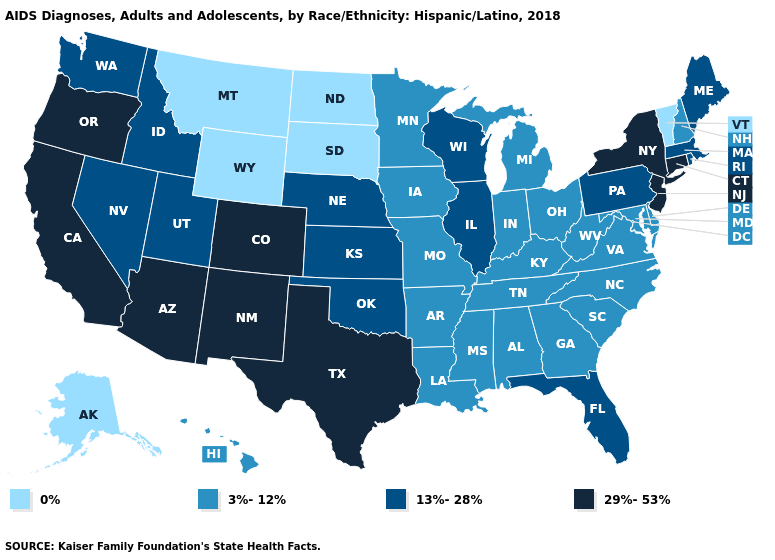Name the states that have a value in the range 3%-12%?
Write a very short answer. Alabama, Arkansas, Delaware, Georgia, Hawaii, Indiana, Iowa, Kentucky, Louisiana, Maryland, Michigan, Minnesota, Mississippi, Missouri, New Hampshire, North Carolina, Ohio, South Carolina, Tennessee, Virginia, West Virginia. Name the states that have a value in the range 0%?
Short answer required. Alaska, Montana, North Dakota, South Dakota, Vermont, Wyoming. What is the highest value in states that border Ohio?
Write a very short answer. 13%-28%. Which states have the lowest value in the USA?
Short answer required. Alaska, Montana, North Dakota, South Dakota, Vermont, Wyoming. Which states have the lowest value in the USA?
Keep it brief. Alaska, Montana, North Dakota, South Dakota, Vermont, Wyoming. Name the states that have a value in the range 29%-53%?
Give a very brief answer. Arizona, California, Colorado, Connecticut, New Jersey, New Mexico, New York, Oregon, Texas. What is the highest value in the USA?
Be succinct. 29%-53%. What is the lowest value in states that border Illinois?
Give a very brief answer. 3%-12%. What is the value of New York?
Short answer required. 29%-53%. Among the states that border West Virginia , does Virginia have the lowest value?
Write a very short answer. Yes. What is the highest value in states that border Arizona?
Quick response, please. 29%-53%. Name the states that have a value in the range 13%-28%?
Short answer required. Florida, Idaho, Illinois, Kansas, Maine, Massachusetts, Nebraska, Nevada, Oklahoma, Pennsylvania, Rhode Island, Utah, Washington, Wisconsin. What is the value of Nevada?
Quick response, please. 13%-28%. What is the value of Montana?
Short answer required. 0%. Does the first symbol in the legend represent the smallest category?
Answer briefly. Yes. 